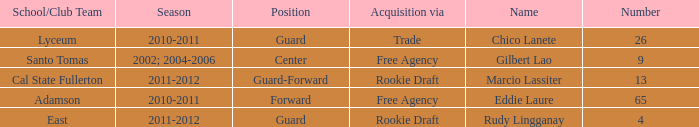What number has an acquisition via the Rookie Draft, and is part of a School/club team at Cal State Fullerton? 13.0. 